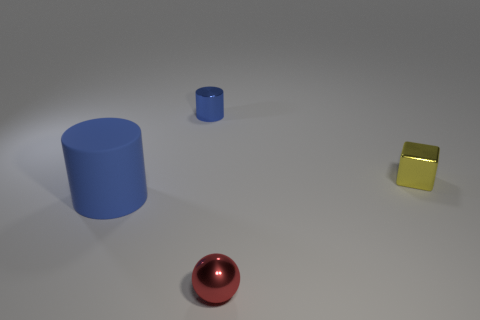Add 1 large yellow metallic cubes. How many objects exist? 5 Subtract all balls. How many objects are left? 3 Add 4 big matte things. How many big matte things exist? 5 Subtract 0 brown cubes. How many objects are left? 4 Subtract all tiny red rubber things. Subtract all small blue metal objects. How many objects are left? 3 Add 2 big blue matte cylinders. How many big blue matte cylinders are left? 3 